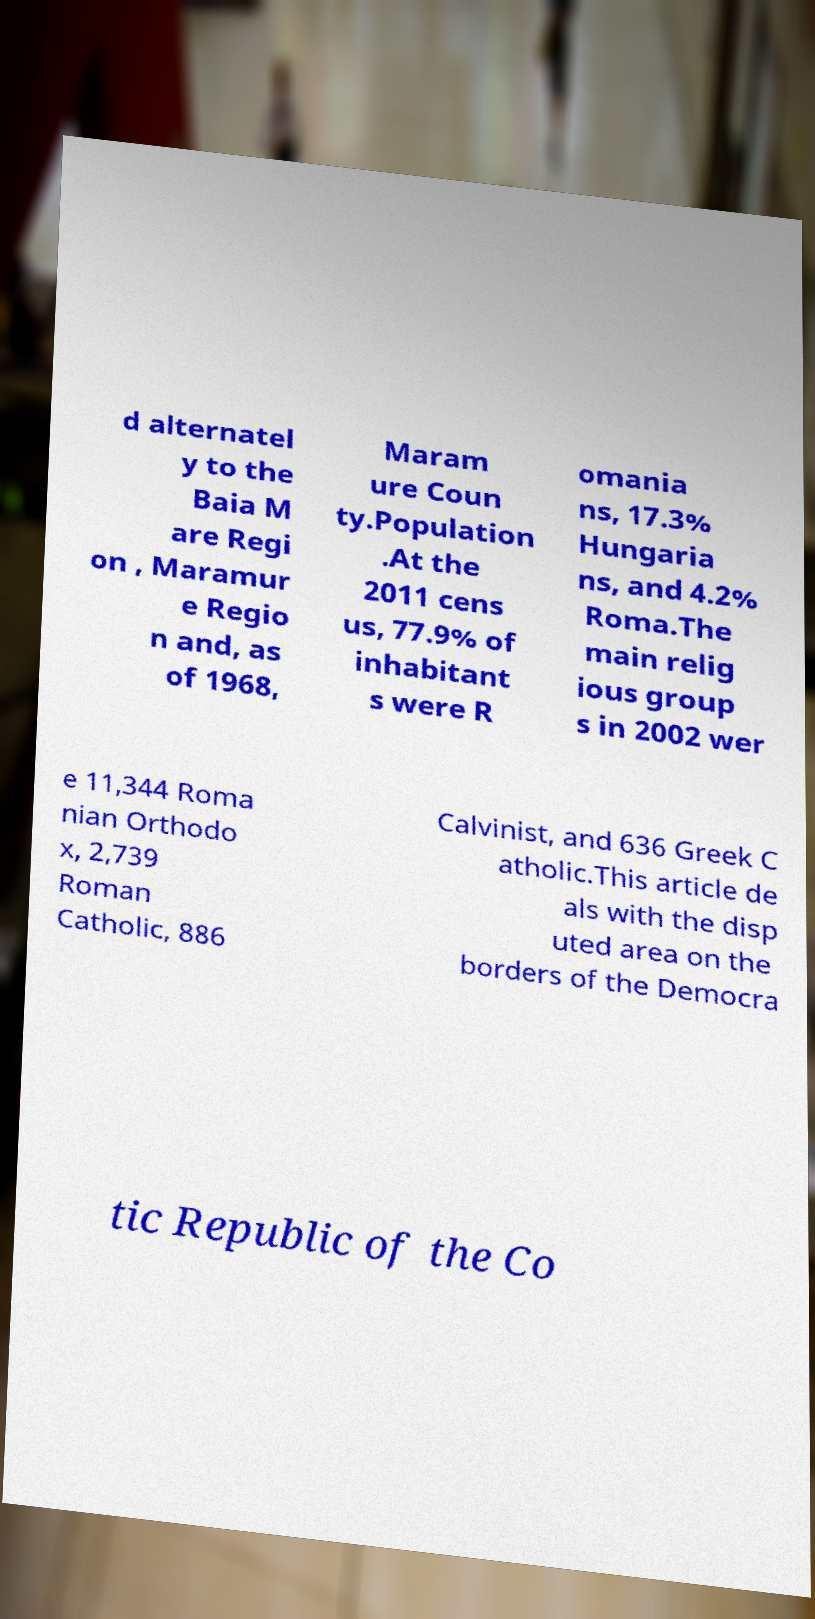Please identify and transcribe the text found in this image. d alternatel y to the Baia M are Regi on , Maramur e Regio n and, as of 1968, Maram ure Coun ty.Population .At the 2011 cens us, 77.9% of inhabitant s were R omania ns, 17.3% Hungaria ns, and 4.2% Roma.The main relig ious group s in 2002 wer e 11,344 Roma nian Orthodo x, 2,739 Roman Catholic, 886 Calvinist, and 636 Greek C atholic.This article de als with the disp uted area on the borders of the Democra tic Republic of the Co 